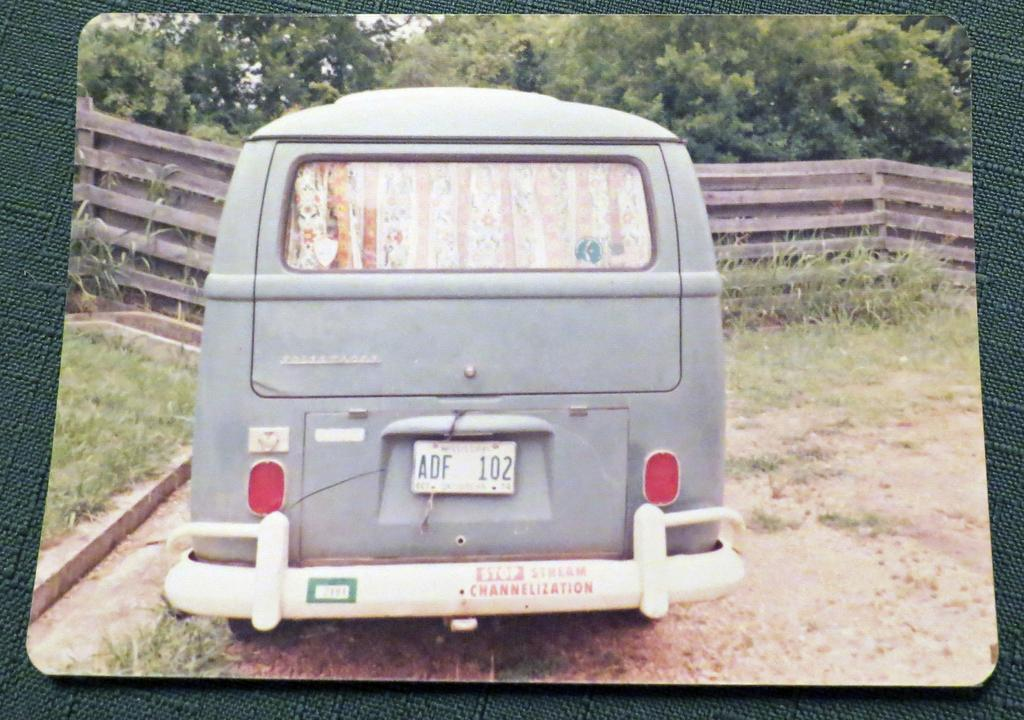What is placed on a surface in the image? There is a photo placed on a surface in the image. What is depicted in the photo? The photo contains a picture of a van. How is the van positioned in the image? The van is placed on the ground. What type of barrier can be seen in the image? There is a wooden fence in the image. What type of vegetation is visible in the image? There is grass visible in the image. What type of natural feature is present in the image? There is a group of trees in the image. Can you tell me how many strangers are standing next to the van in the image? There are no strangers present in the image; it only contains a photo of a van placed on the ground. What type of thrill can be experienced by the van in the image? The van is stationary in the image, so it is not experiencing any thrill. 